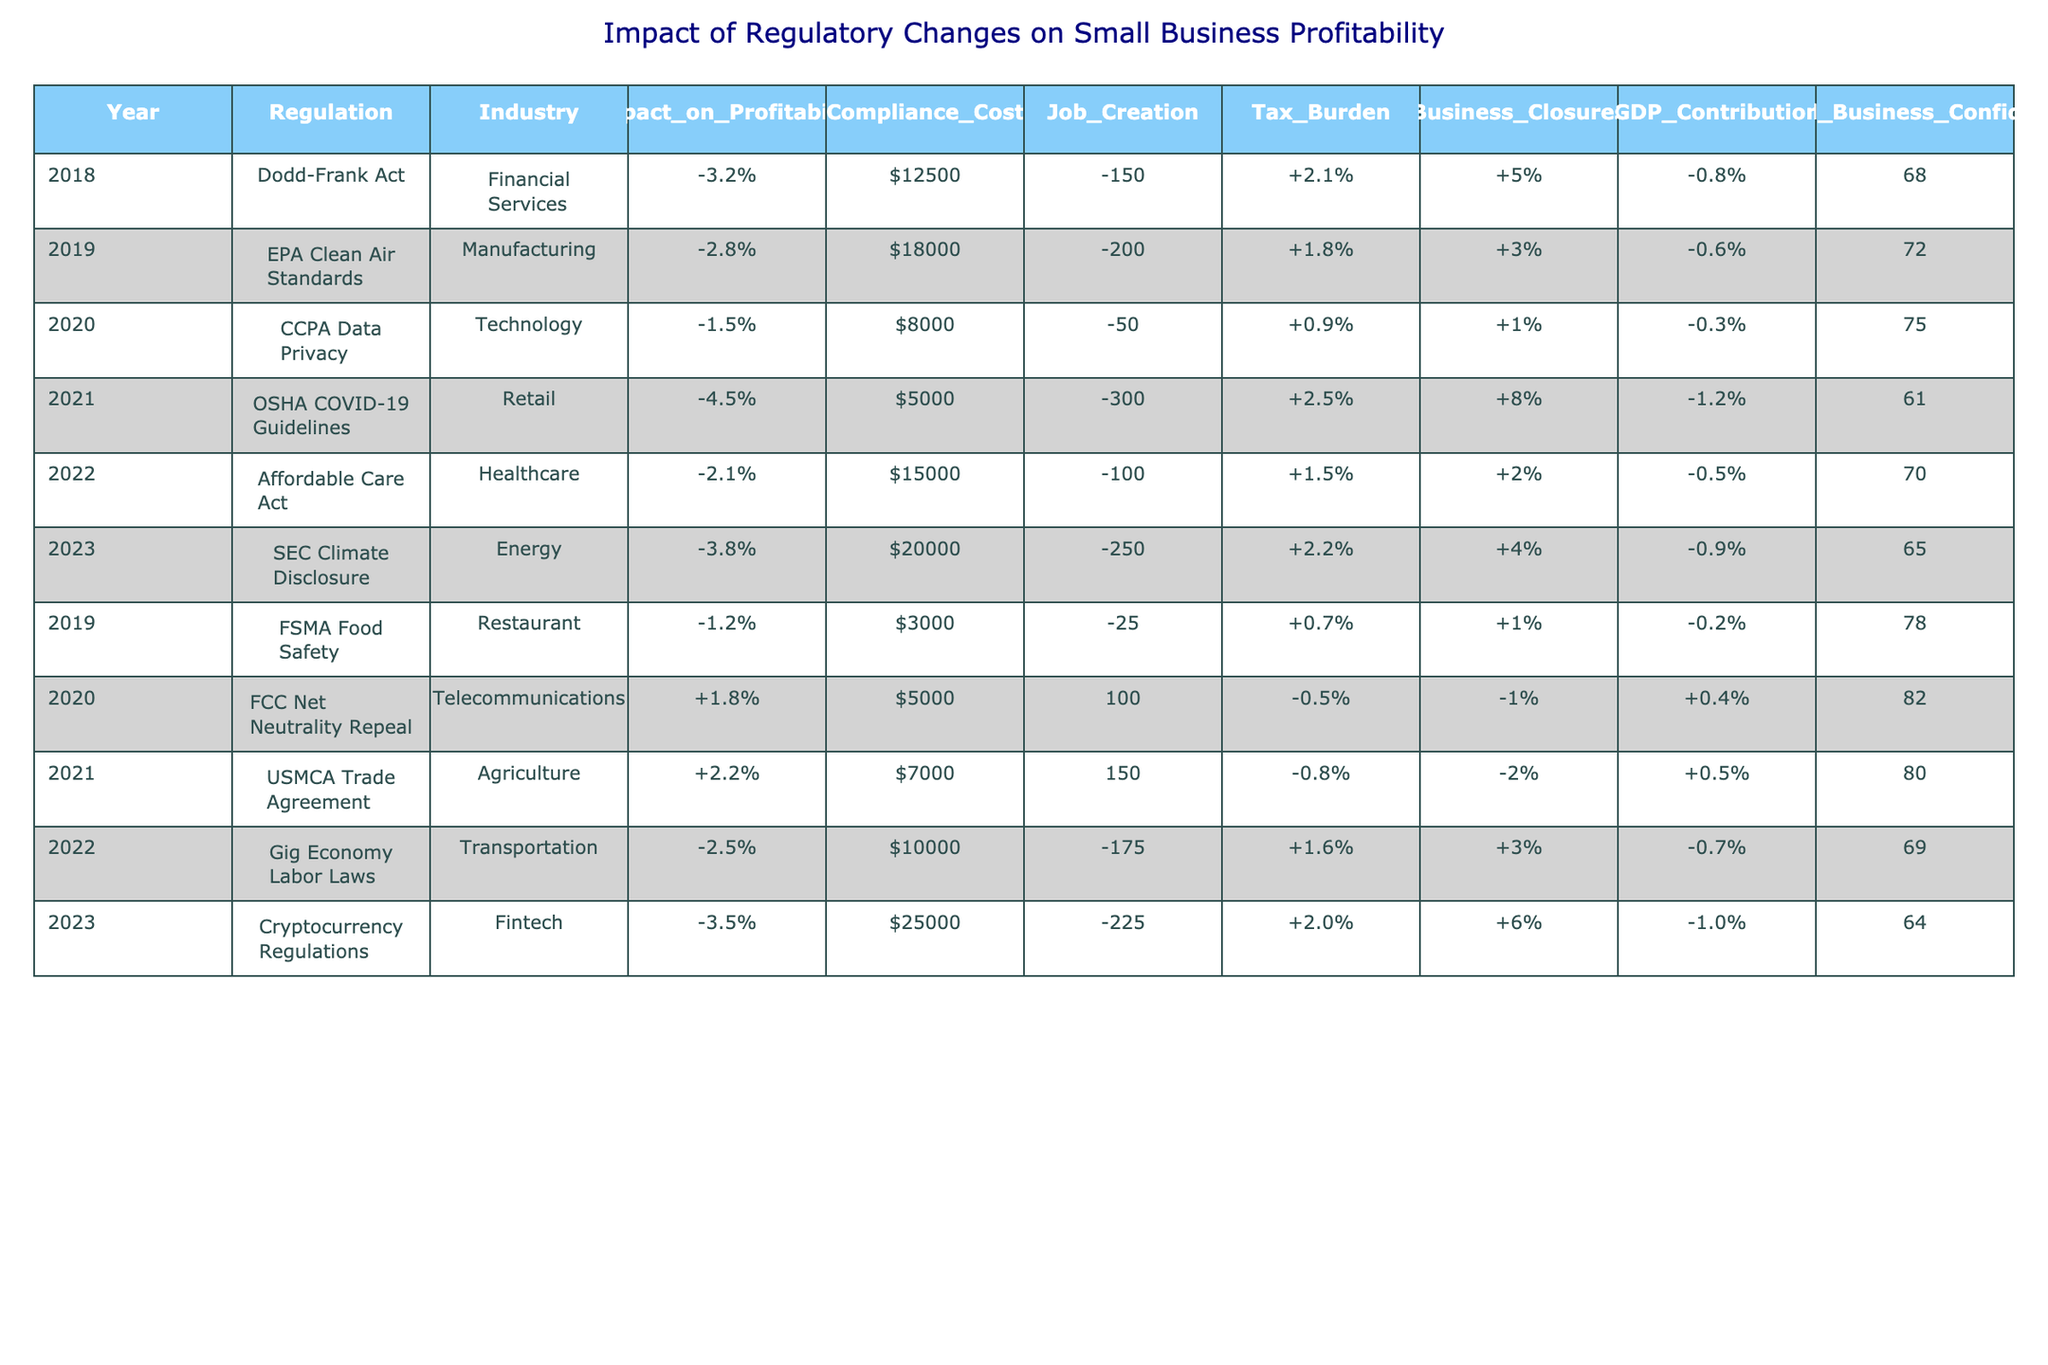What regulation had the highest negative impact on profitability? The table shows the 'Impact_on_Profitability' values for each regulation. The lowest value is -4.5%, associated with the OSHA COVID-19 Guidelines in 2021.
Answer: -4.5% What was the compliance cost for the SEC Climate Disclosure regulation in 2023? Referring to the table, the 'Compliance_Cost' for the SEC Climate Disclosure in 2023 is $20,000.
Answer: $20,000 How many jobs were created according to the Dodd-Frank Act in 2018? The table specifies 'Job_Creation' for the Dodd-Frank Act in 2018 as -150 jobs.
Answer: -150 What was the average impact on profitability for regulations that had a positive impact? The regulations with positive profitability impacts are FCC Net Neutrality Repeal (+1.8%) and USMCA Trade Agreement (+2.2%). Adding these gives 1.8 + 2.2 = 4.0%. Averaging gives 4.0% / 2 = 2.0%.
Answer: 2.0% Did the Affordable Care Act have a lower compliance cost than the SEC Climate Disclosure? A comparison of the compliance costs shows $15,000 for the Affordable Care Act and $20,000 for the SEC Climate Disclosure, indicating that the ACA had a lower compliance cost.
Answer: Yes What is the total job creation loss for all regulations listed in the table? First, sum all 'Job_Creation' values: -150 - 200 - 50 - 300 - 100 - 250 - 25 + 100 + 150 - 175 - 225. The total loss comes to -1,025 jobs.
Answer: -1,025 Which year saw the highest contribution to GDP from a regulation? Checking the 'GDP_Contribution' in the table, the highest value is +8% from the OSHA COVID-19 Guidelines in 2021.
Answer: +8% What is the change in small business confidence from 2018 to 2023? Small business confidence in 2018 is 68, and in 2023 it is 64. The change is 64 - 68 = -4, indicating a decline in confidence.
Answer: -4 Which industry faced the highest tax burden according to the regulations? The regulations in the table indicate that the highest tax burden is described as +8% for the OSHA COVID-19 Guidelines in 2021.
Answer: +8% Was the impact on profitability for the EPA Clean Air Standards worse than for the CCPA Data Privacy regulation? The impact values are -2.8% for the EPA Clean Air Standards and -1.5% for the CCPA Data Privacy. Since -2.8% is more negative than -1.5%, it was worse.
Answer: Yes How many total business closures are recorded for all the regulations combined? Adding the 'Business_Closures' values results in -0.8 - 0.6 - 0.3 - 1.2 - 0.5 - 0.9 - 0.2 + 0.4 + 0.5 - 0.7 - 1.0, giving a total of -7.9%.
Answer: -7.9% 